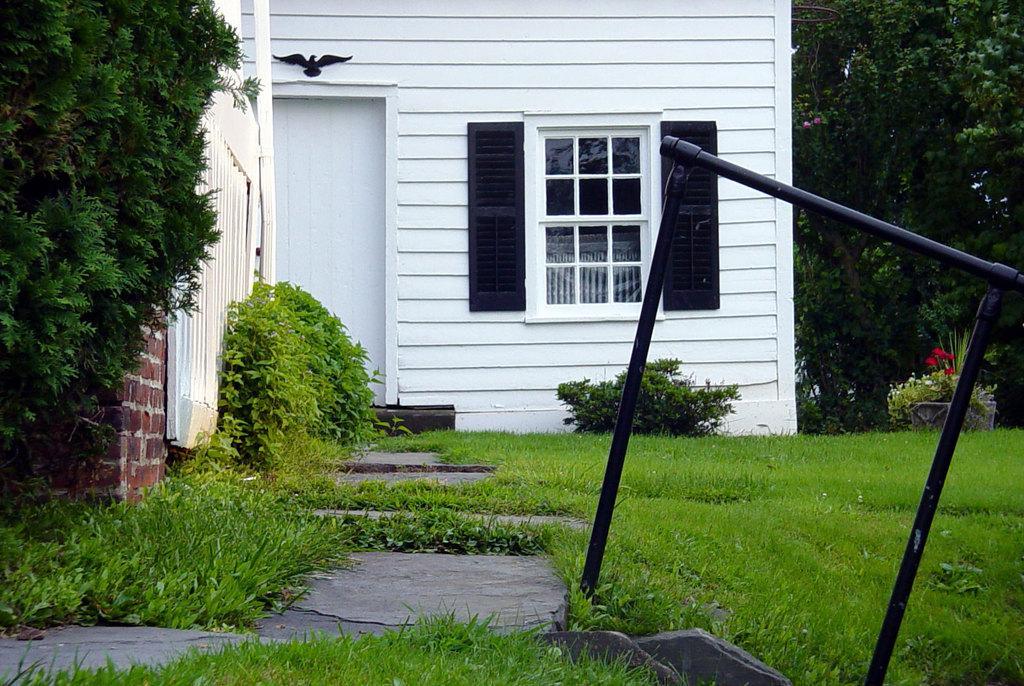Please provide a concise description of this image. This image is taken outdoors. At the bottom of the image there is a ground with grass on it. On the right side of the image there is a metal rod. There are a few trees and plants on the ground. In the middle of the image there is a house with walls, a window and a door. There are few plants with leaves. On the left side of the image there is a tree with leaves, stems and branches. 